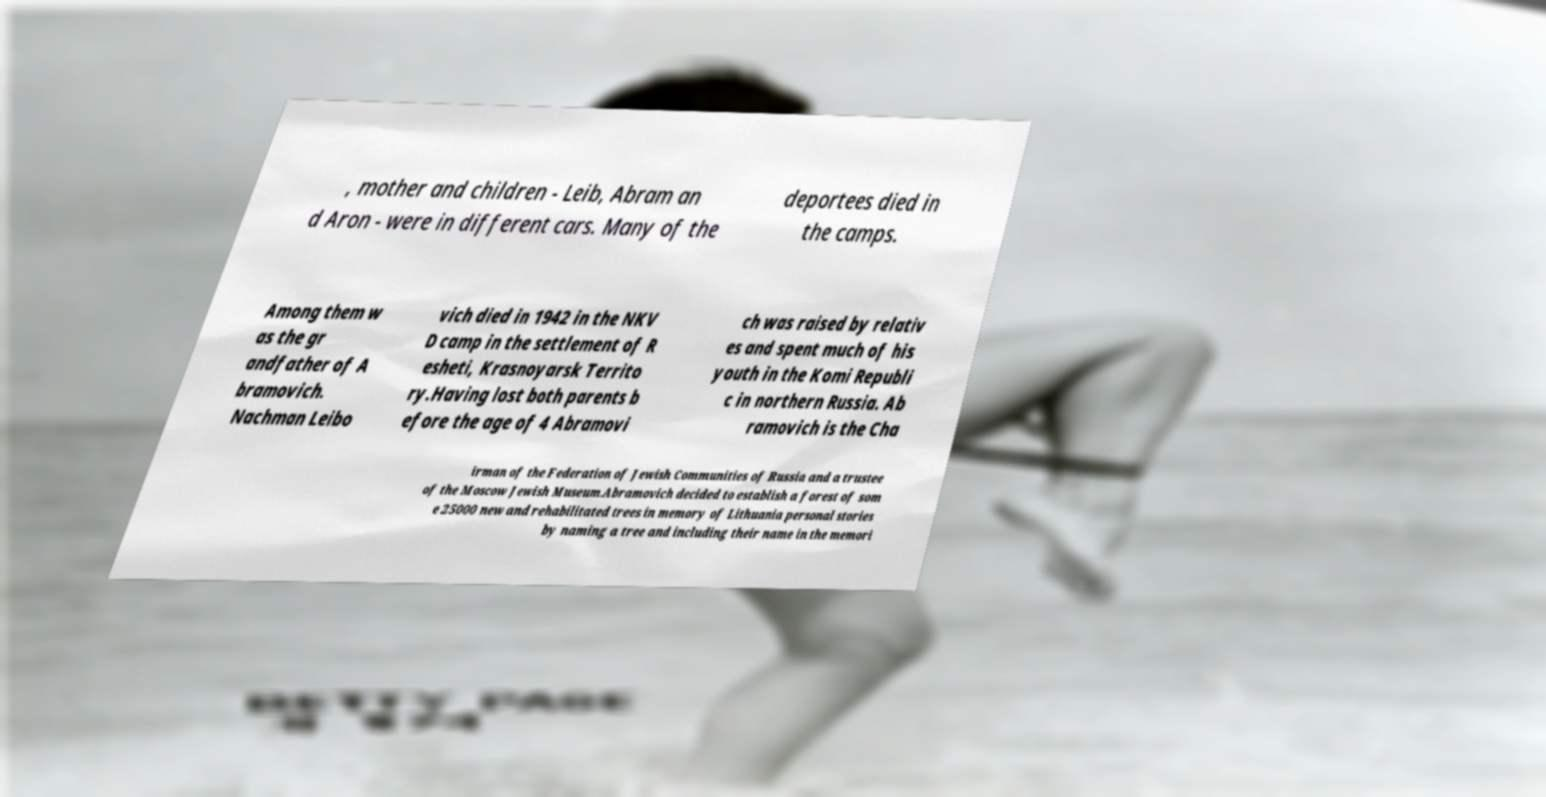Can you read and provide the text displayed in the image?This photo seems to have some interesting text. Can you extract and type it out for me? , mother and children - Leib, Abram an d Aron - were in different cars. Many of the deportees died in the camps. Among them w as the gr andfather of A bramovich. Nachman Leibo vich died in 1942 in the NKV D camp in the settlement of R esheti, Krasnoyarsk Territo ry.Having lost both parents b efore the age of 4 Abramovi ch was raised by relativ es and spent much of his youth in the Komi Republi c in northern Russia. Ab ramovich is the Cha irman of the Federation of Jewish Communities of Russia and a trustee of the Moscow Jewish Museum.Abramovich decided to establish a forest of som e 25000 new and rehabilitated trees in memory of Lithuania personal stories by naming a tree and including their name in the memori 